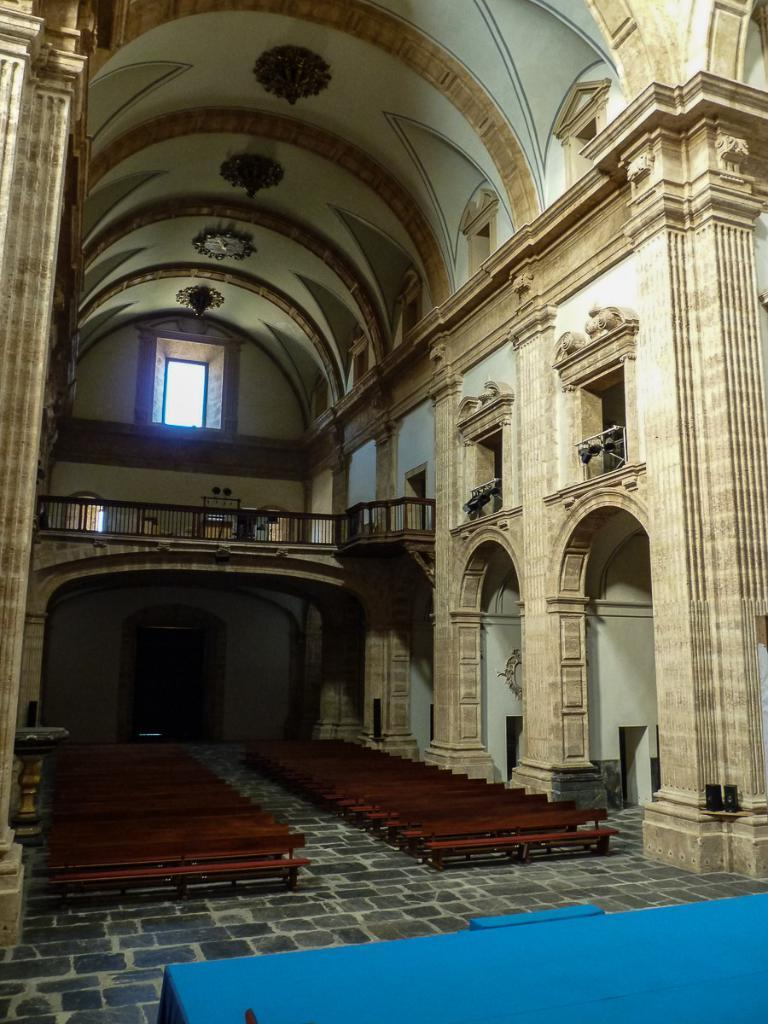What type of location is depicted in the image? The image shows the interior of a building. What type of furniture is present in the building? There are benches in the building. What safety feature is present in the building? Railings are present in the building. What provides illumination in the building? Lights are visible in the building. What other objects can be seen in the building? There are other objects in the building, but their specific details are not mentioned in the facts. What type of decorative elements are present on the walls of the building? Architecture designs are present on the walls of the building. How many mice can be seen running on the benches in the image? There are no mice present in the image; it shows the interior of a building with benches, railings, lights, and architecture designs on the walls. What type of request can be made to the earth in the image? There is no reference to the earth or any requests in the image; it depicts the interior of a building with various features and objects. 